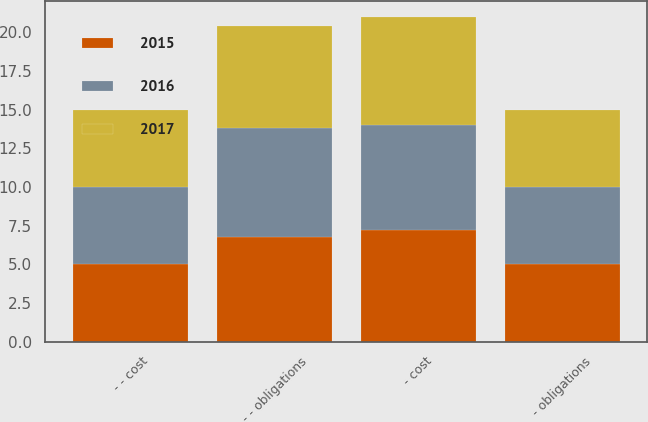<chart> <loc_0><loc_0><loc_500><loc_500><stacked_bar_chart><ecel><fcel>- - obligations<fcel>- cost<fcel>- obligations<fcel>- - cost<nl><fcel>2017<fcel>6.6<fcel>7<fcel>5<fcel>5<nl><fcel>2016<fcel>7<fcel>6.8<fcel>5<fcel>5<nl><fcel>2015<fcel>6.8<fcel>7.2<fcel>5<fcel>5<nl></chart> 